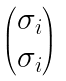Convert formula to latex. <formula><loc_0><loc_0><loc_500><loc_500>\begin{pmatrix} \sigma _ { i } \\ \sigma _ { i } \end{pmatrix}</formula> 